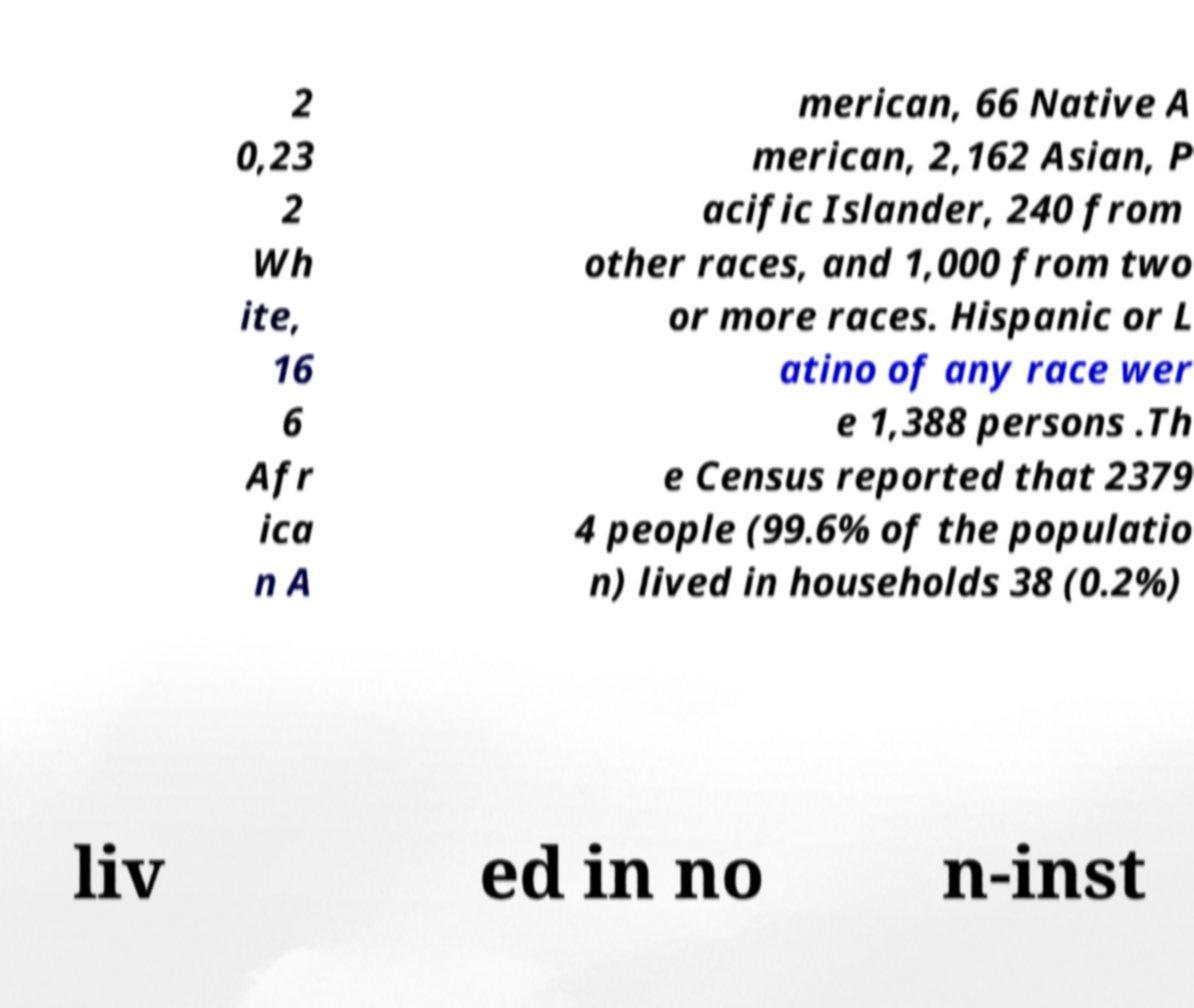Can you read and provide the text displayed in the image?This photo seems to have some interesting text. Can you extract and type it out for me? 2 0,23 2 Wh ite, 16 6 Afr ica n A merican, 66 Native A merican, 2,162 Asian, P acific Islander, 240 from other races, and 1,000 from two or more races. Hispanic or L atino of any race wer e 1,388 persons .Th e Census reported that 2379 4 people (99.6% of the populatio n) lived in households 38 (0.2%) liv ed in no n-inst 